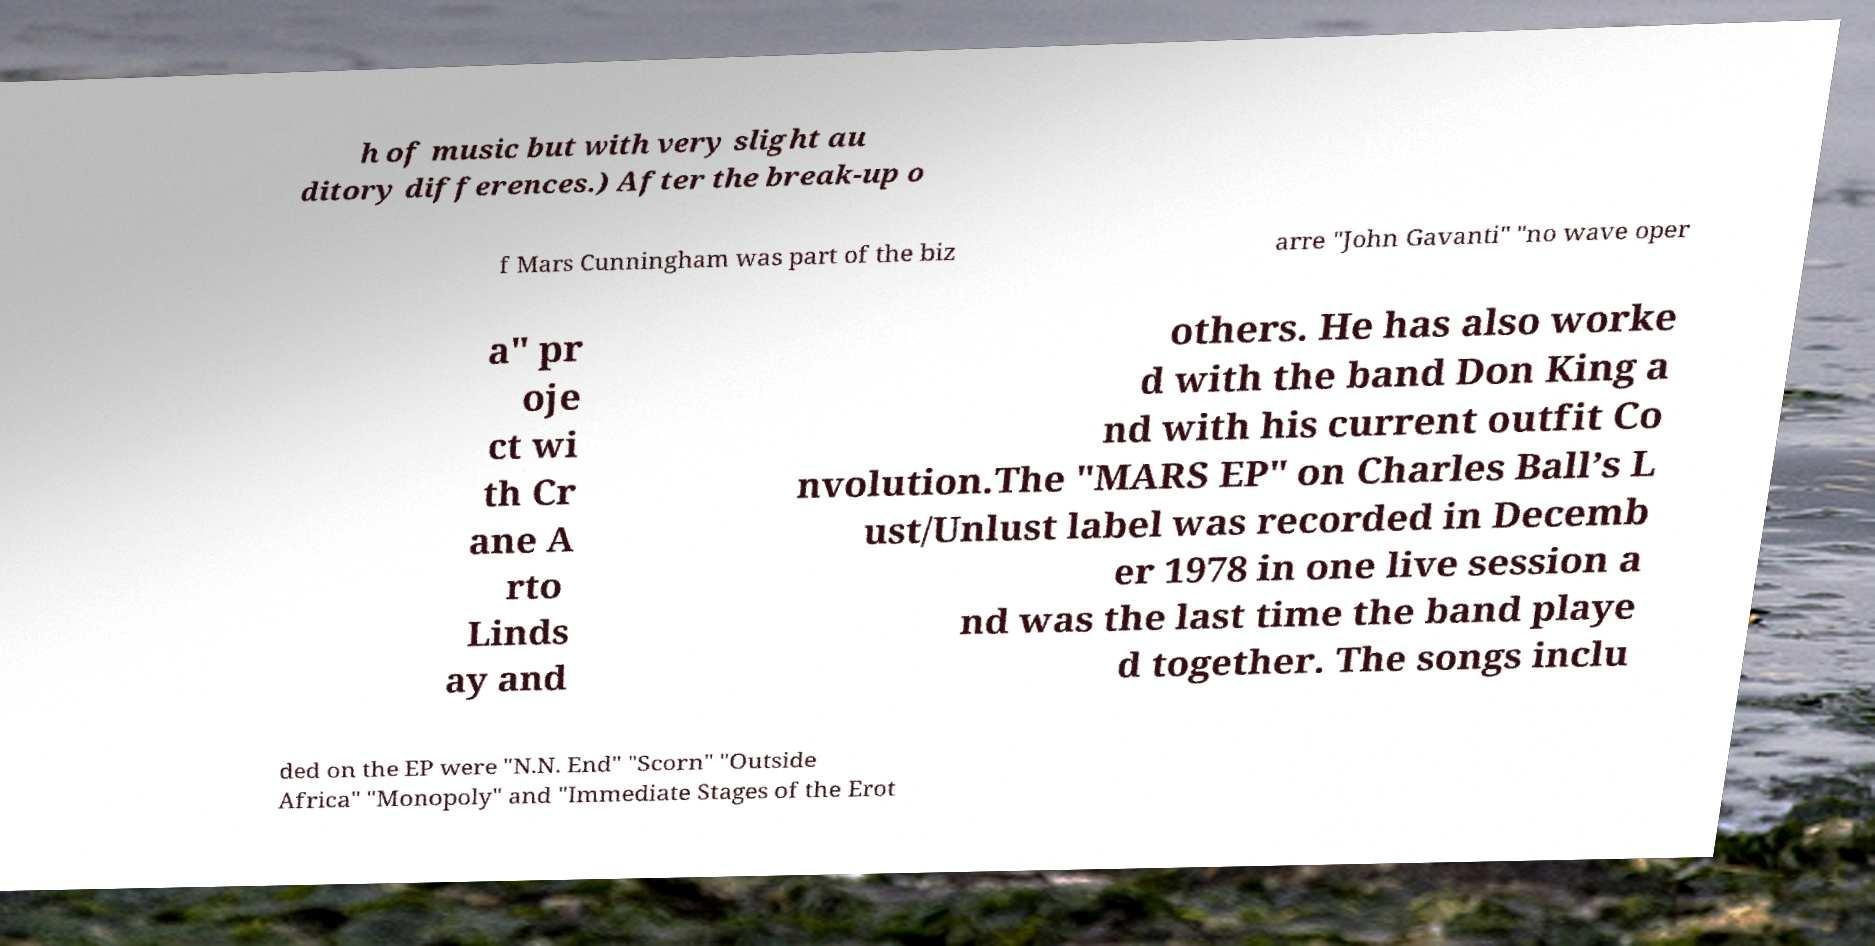I need the written content from this picture converted into text. Can you do that? h of music but with very slight au ditory differences.) After the break-up o f Mars Cunningham was part of the biz arre "John Gavanti" "no wave oper a" pr oje ct wi th Cr ane A rto Linds ay and others. He has also worke d with the band Don King a nd with his current outfit Co nvolution.The "MARS EP" on Charles Ball’s L ust/Unlust label was recorded in Decemb er 1978 in one live session a nd was the last time the band playe d together. The songs inclu ded on the EP were "N.N. End" "Scorn" "Outside Africa" "Monopoly" and "Immediate Stages of the Erot 